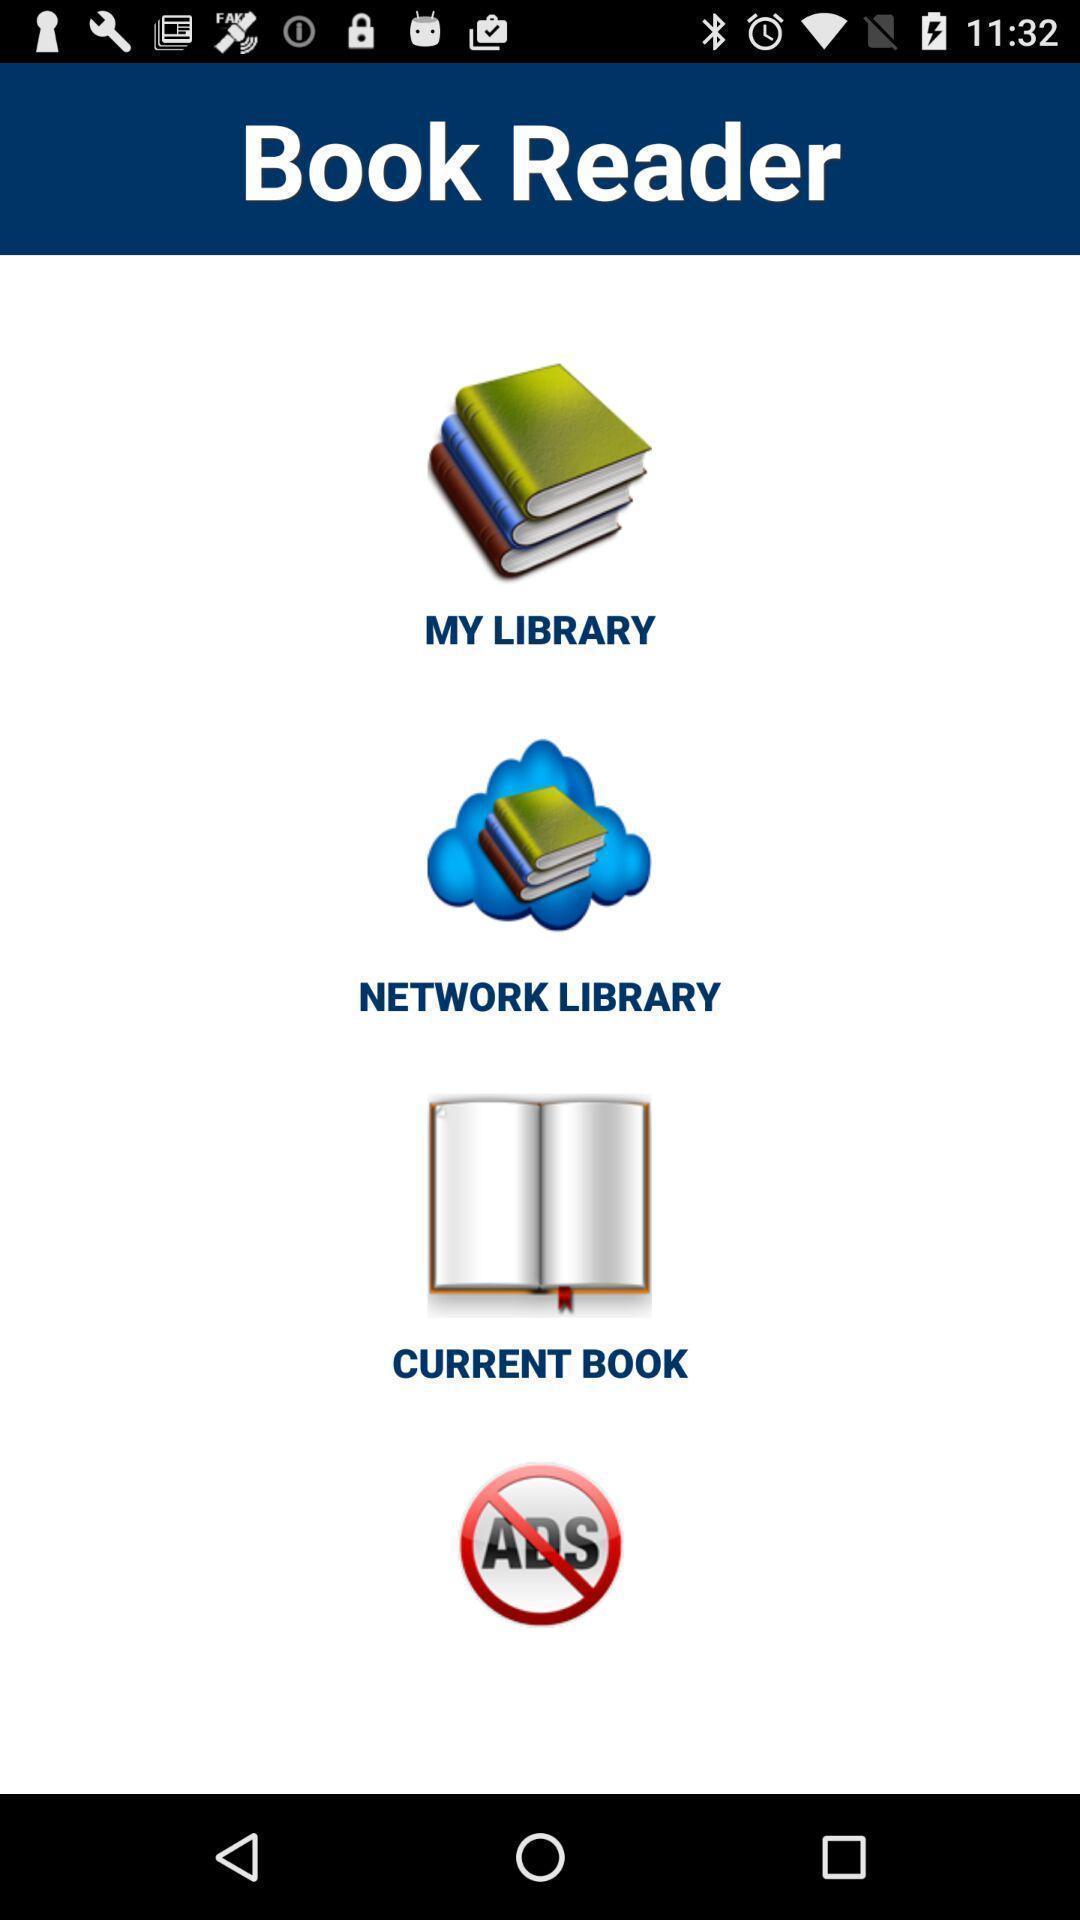Describe this image in words. Screen shows a list of book readers. 